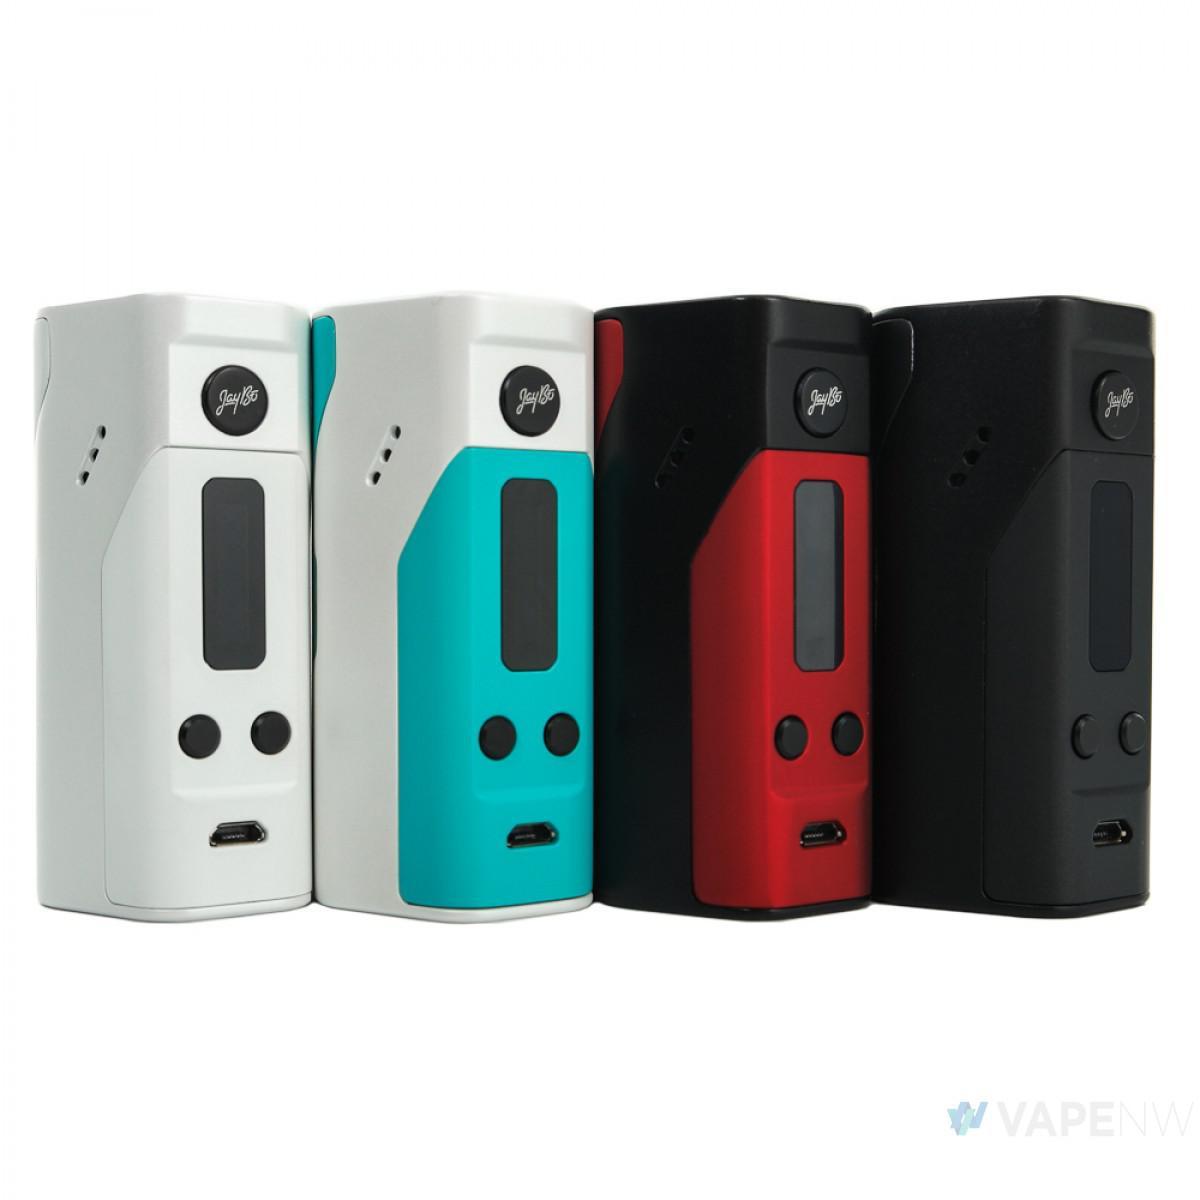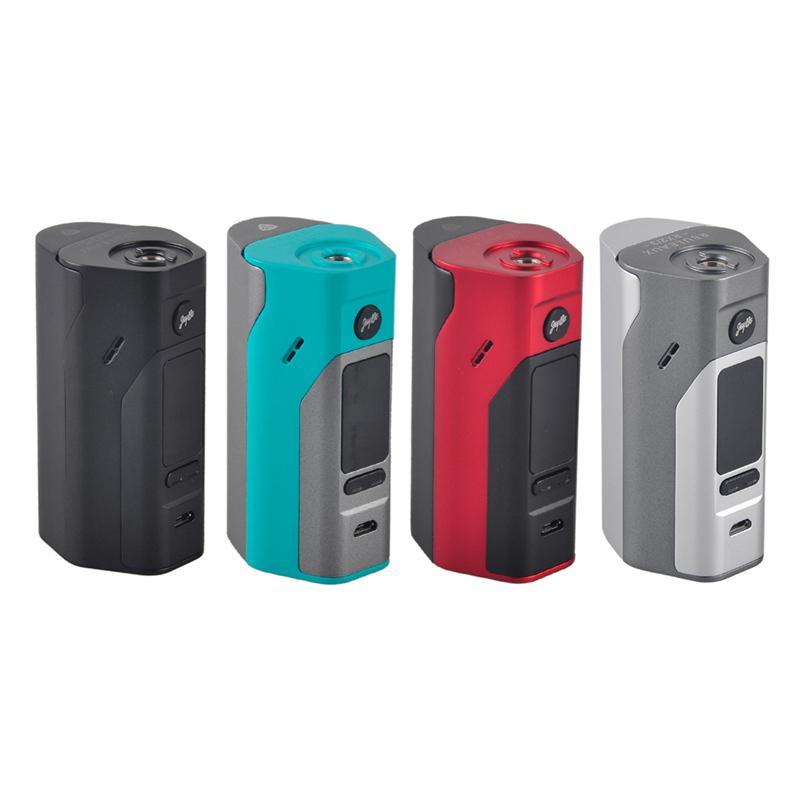The first image is the image on the left, the second image is the image on the right. Considering the images on both sides, is "The right image contains exactly four vape devices." valid? Answer yes or no. Yes. The first image is the image on the left, the second image is the image on the right. Assess this claim about the two images: "The same number of phones, each sporting a distinct color design, is in each image.". Correct or not? Answer yes or no. Yes. 